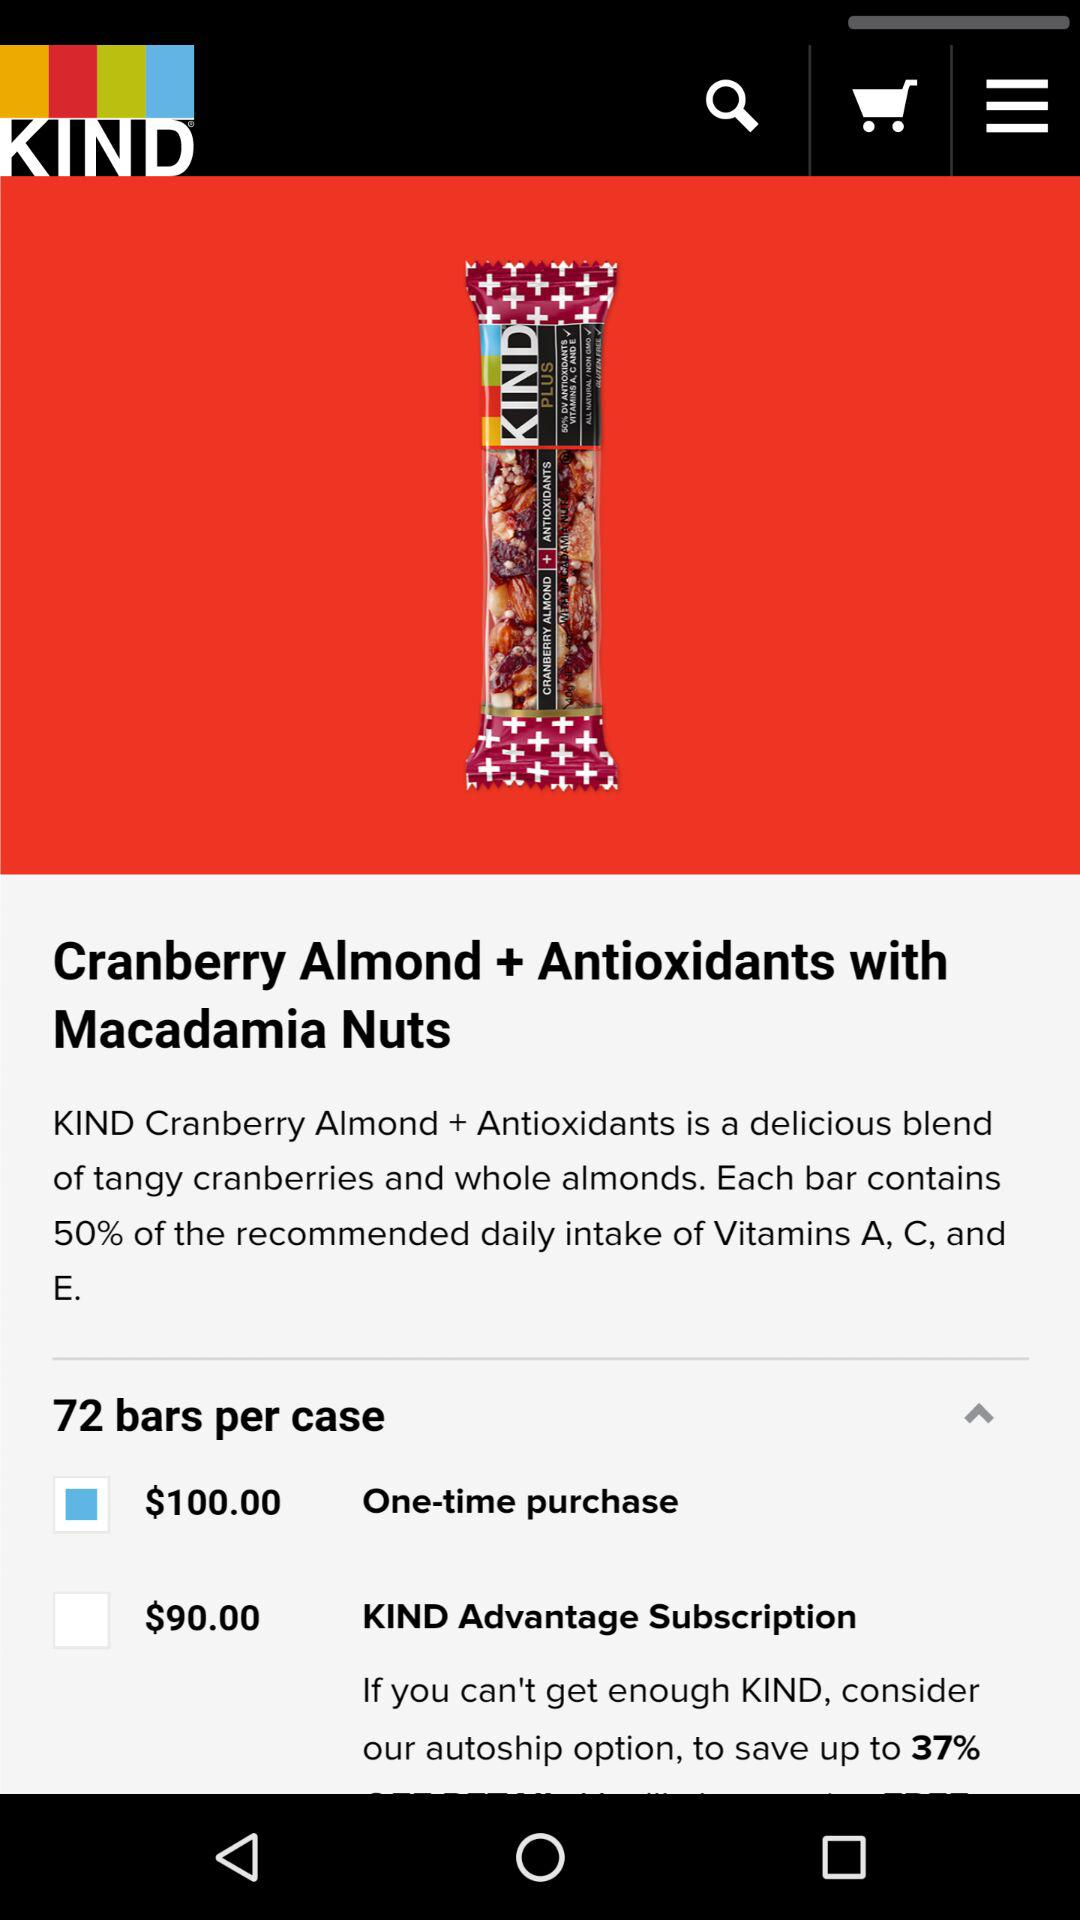What is the price of the product after the subscription? The price is $90. 